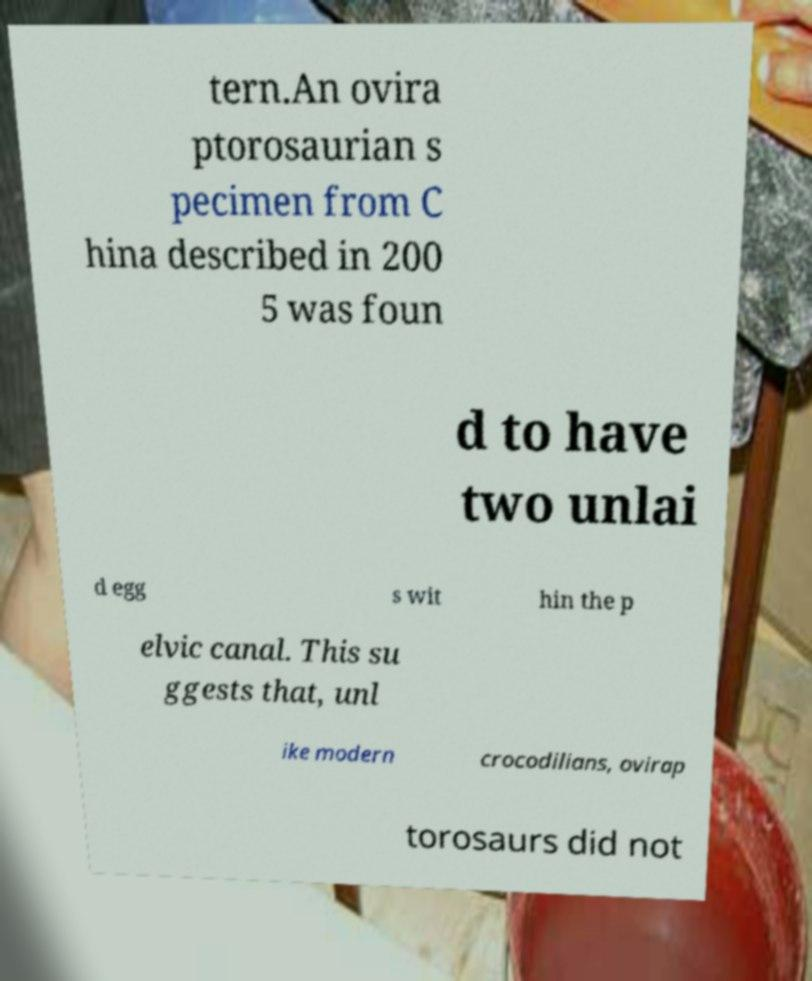Could you extract and type out the text from this image? tern.An ovira ptorosaurian s pecimen from C hina described in 200 5 was foun d to have two unlai d egg s wit hin the p elvic canal. This su ggests that, unl ike modern crocodilians, ovirap torosaurs did not 